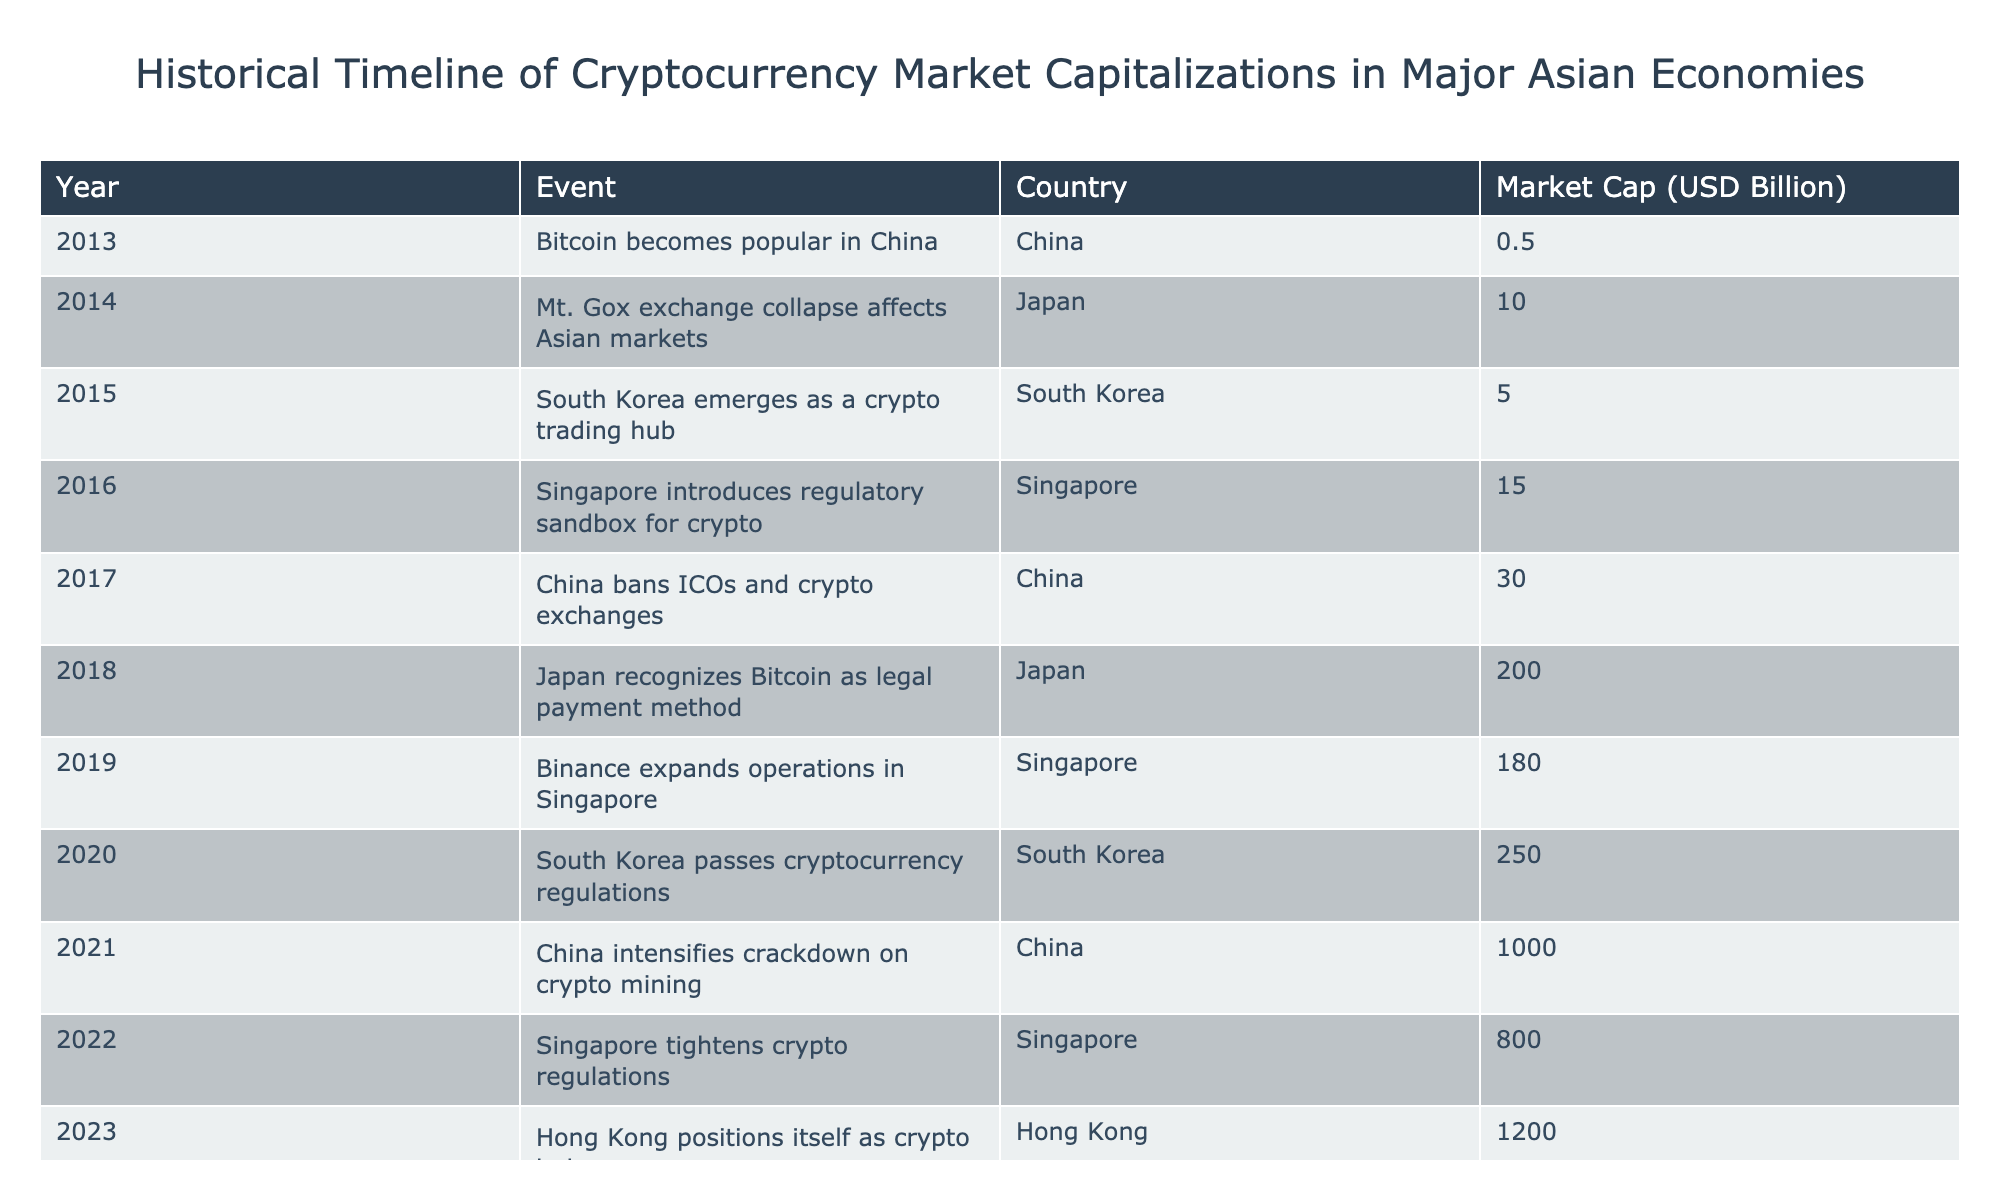What was the market capitalization of cryptocurrencies in China in 2017? In 2017, the table indicates that China had a market cap of 30 billion USD as cryptocurrencies faced a ban on ICOs and exchanges.
Answer: 30 billion USD What event in Singapore occurred in 2016 and what was its market cap? The table states that in 2016, Singapore introduced a regulatory sandbox for cryptocurrencies, resulting in a market cap of 15 billion USD.
Answer: 15 billion USD What was the percentage increase in market cap for South Korea from 2015 to 2020? In 2015, South Korea had a market cap of 5 billion USD, and by 2020, it increased to 250 billion USD. The increase is 250 - 5 = 245 billion USD. To find the percentage increase, we divide the increase by the original value: (245/5) * 100 = 4900%.
Answer: 4900% Did Japan recognize Bitcoin as a legal payment method before or after China banned ICOs? According to the table, Japan recognized Bitcoin as a legal payment method in 2018, which is after China banned ICOs in 2017.
Answer: After What was the total market capitalization of cryptocurrencies in Singapore by 2022? By 2022, the table shows that Singapore had a market cap of 800 billion USD. This is a high value and reflects the impact of tightened regulations on the market.
Answer: 800 billion USD Which country had the highest market cap in 2023, and what was that amount? The data indicates that in 2023, Hong Kong had the highest market cap of 1200 billion USD, positioning itself as a crypto hub.
Answer: 1200 billion USD What was the overall change in market capitalization from Japan's event in 2014 to Hong Kong in 2023? In 2014, Japan had a market cap of 10 billion USD and by 2023, Hong Kong reached 1200 billion USD. The overall change is 1200 - 10 = 1190 billion USD, indicating significant growth in the market.
Answer: 1190 billion USD Is there an event in the timeline where Singapore saw a decrease in market capitalization? The table does not indicate any decrease in market capitalization for Singapore; it shows an upward trend in the values for both 2016 (15 billion USD) and 2019 (180 billion USD).
Answer: No Which country showed a significant shift in regulations in both 2020 and 2022, and how did their market cap change during this period? South Korea passed cryptocurrency regulations in 2020 with a market cap of 250 billion USD and faced no declines in regulations or market cap in 2022. In contrast, Singapore saw tighter regulations in 2022 but still maintained a high cap at 800 billion USD. South Korea's market cap grew significantly, indicating positive regulatory support.
Answer: South Korea 